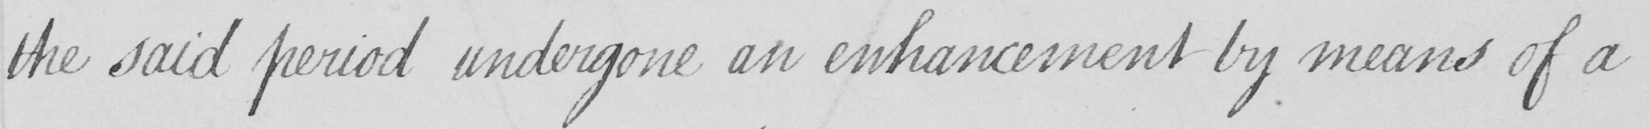Please transcribe the handwritten text in this image. the said period undergone an enhancement by means of a 